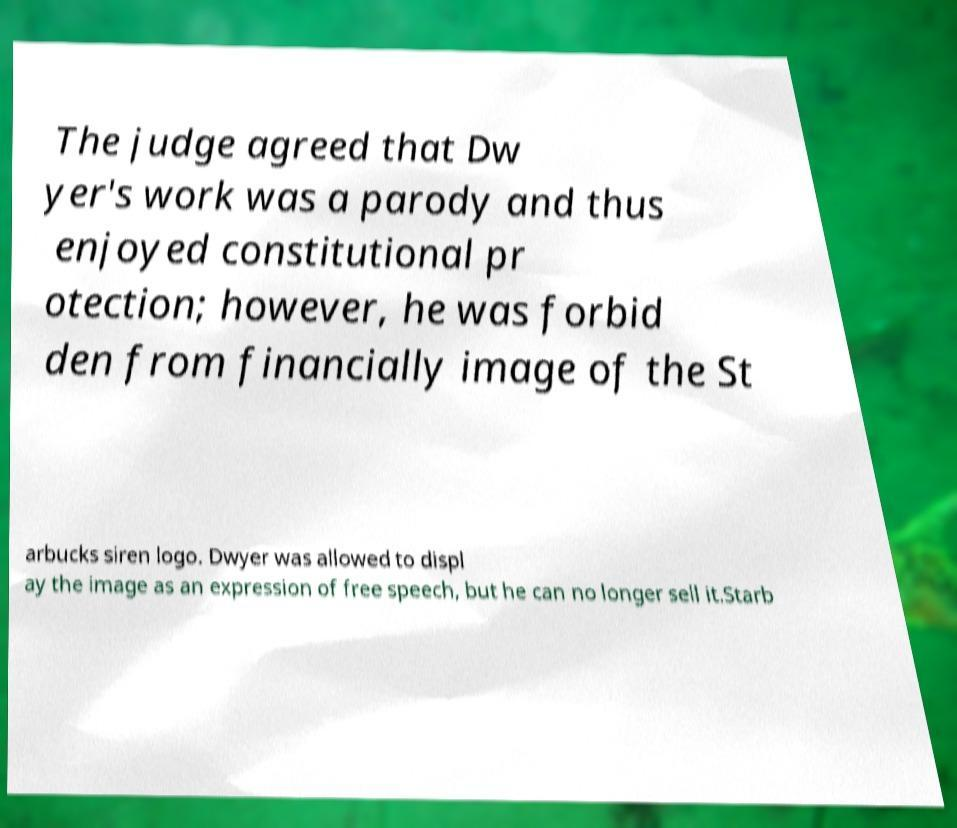Can you read and provide the text displayed in the image?This photo seems to have some interesting text. Can you extract and type it out for me? The judge agreed that Dw yer's work was a parody and thus enjoyed constitutional pr otection; however, he was forbid den from financially image of the St arbucks siren logo. Dwyer was allowed to displ ay the image as an expression of free speech, but he can no longer sell it.Starb 